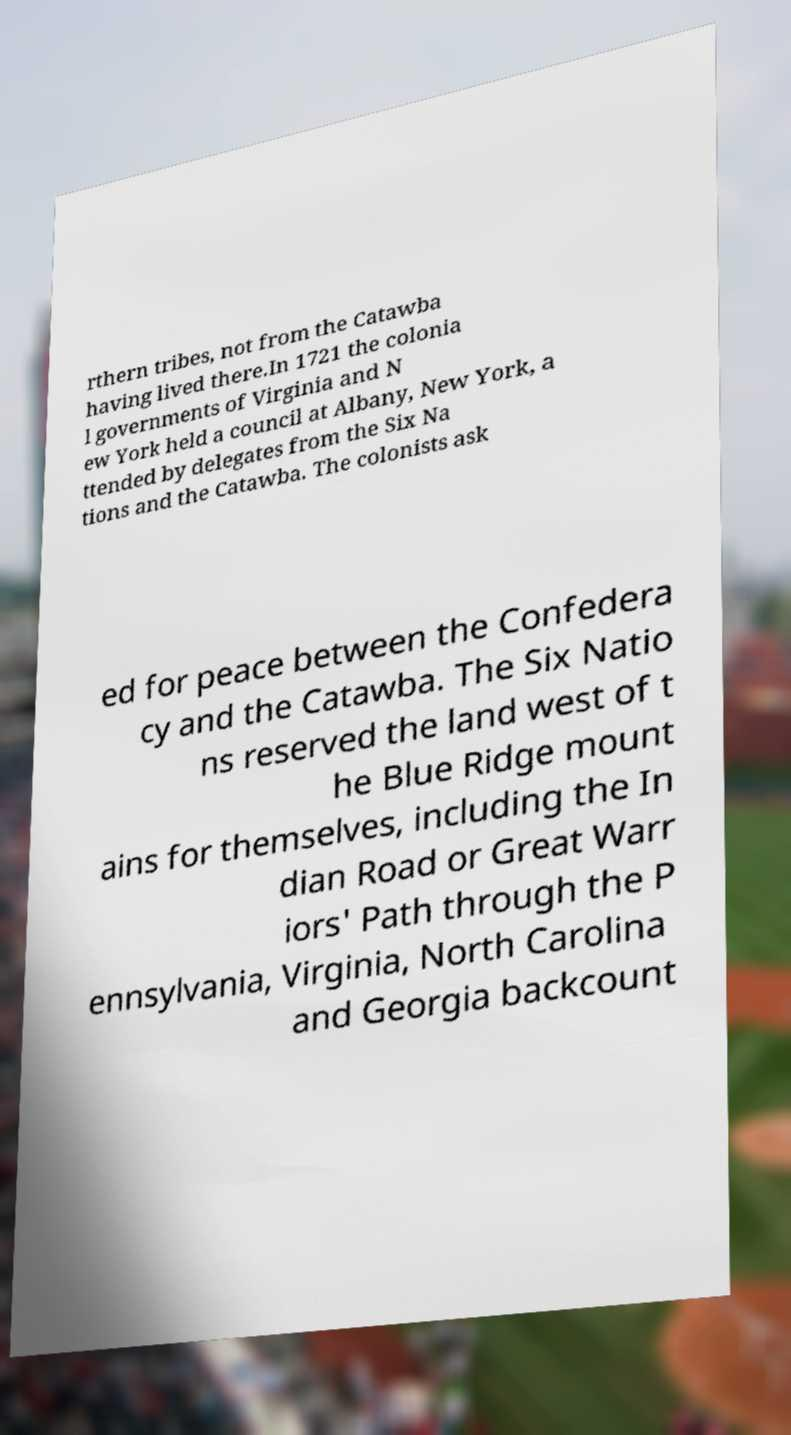Could you assist in decoding the text presented in this image and type it out clearly? rthern tribes, not from the Catawba having lived there.In 1721 the colonia l governments of Virginia and N ew York held a council at Albany, New York, a ttended by delegates from the Six Na tions and the Catawba. The colonists ask ed for peace between the Confedera cy and the Catawba. The Six Natio ns reserved the land west of t he Blue Ridge mount ains for themselves, including the In dian Road or Great Warr iors' Path through the P ennsylvania, Virginia, North Carolina and Georgia backcount 